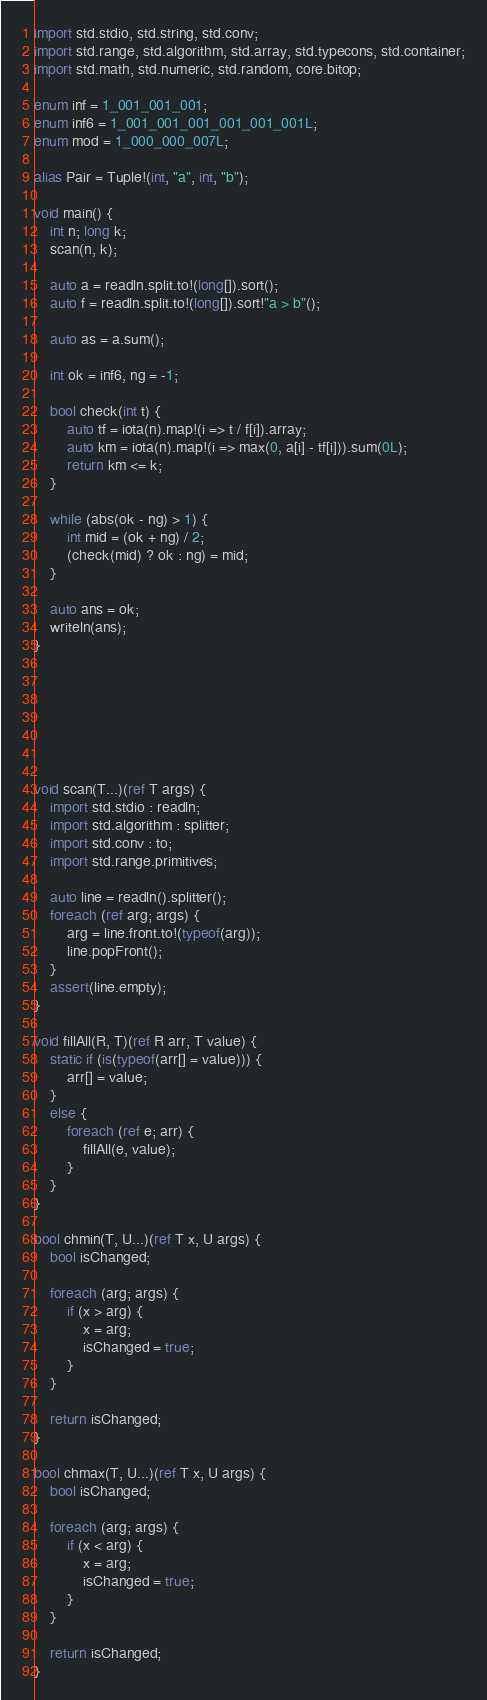<code> <loc_0><loc_0><loc_500><loc_500><_D_>import std.stdio, std.string, std.conv;
import std.range, std.algorithm, std.array, std.typecons, std.container;
import std.math, std.numeric, std.random, core.bitop;

enum inf = 1_001_001_001;
enum inf6 = 1_001_001_001_001_001_001L;
enum mod = 1_000_000_007L;

alias Pair = Tuple!(int, "a", int, "b");

void main() {
    int n; long k;
    scan(n, k);

    auto a = readln.split.to!(long[]).sort();
    auto f = readln.split.to!(long[]).sort!"a > b"();

    auto as = a.sum();

    int ok = inf6, ng = -1;

    bool check(int t) {
        auto tf = iota(n).map!(i => t / f[i]).array;
        auto km = iota(n).map!(i => max(0, a[i] - tf[i])).sum(0L);
        return km <= k;
    }

    while (abs(ok - ng) > 1) {
        int mid = (ok + ng) / 2;
        (check(mid) ? ok : ng) = mid;
    }

    auto ans = ok;
    writeln(ans);
}







void scan(T...)(ref T args) {
    import std.stdio : readln;
    import std.algorithm : splitter;
    import std.conv : to;
    import std.range.primitives;

    auto line = readln().splitter();
    foreach (ref arg; args) {
        arg = line.front.to!(typeof(arg));
        line.popFront();
    }
    assert(line.empty);
}

void fillAll(R, T)(ref R arr, T value) {
    static if (is(typeof(arr[] = value))) {
        arr[] = value;
    }
    else {
        foreach (ref e; arr) {
            fillAll(e, value);
        }
    }
}

bool chmin(T, U...)(ref T x, U args) {
    bool isChanged;

    foreach (arg; args) {
        if (x > arg) {
            x = arg;
            isChanged = true;
        }
    }

    return isChanged;
}

bool chmax(T, U...)(ref T x, U args) {
    bool isChanged;

    foreach (arg; args) {
        if (x < arg) {
            x = arg;
            isChanged = true;
        }
    }

    return isChanged;
}
</code> 